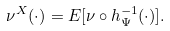Convert formula to latex. <formula><loc_0><loc_0><loc_500><loc_500>\nu ^ { X } ( \cdot ) = E [ \nu \circ h _ { \Psi } ^ { - 1 } ( \cdot ) ] .</formula> 